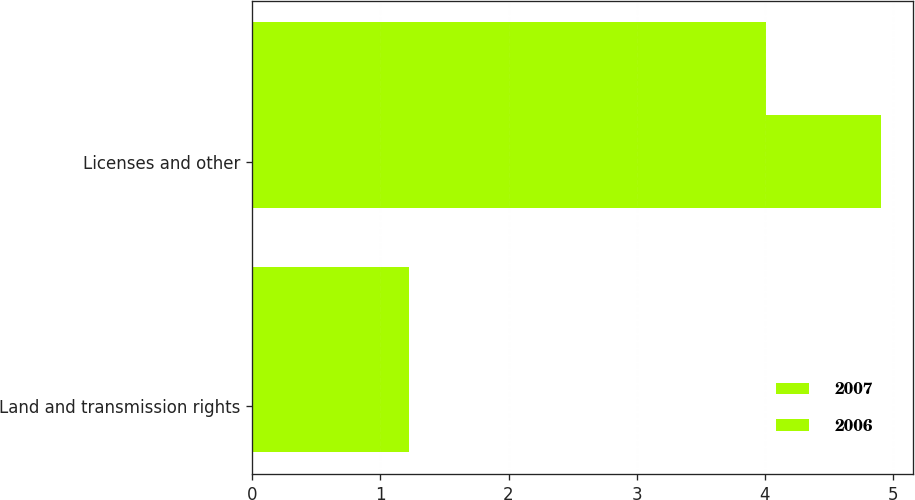<chart> <loc_0><loc_0><loc_500><loc_500><stacked_bar_chart><ecel><fcel>Land and transmission rights<fcel>Licenses and other<nl><fcel>2007<fcel>1.22<fcel>4.91<nl><fcel>2006<fcel>1.22<fcel>4.01<nl></chart> 